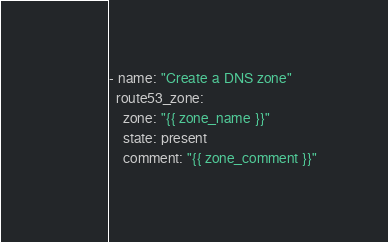<code> <loc_0><loc_0><loc_500><loc_500><_YAML_>- name: "Create a DNS zone"
  route53_zone:
    zone: "{{ zone_name }}"
    state: present
    comment: "{{ zone_comment }}"
</code> 